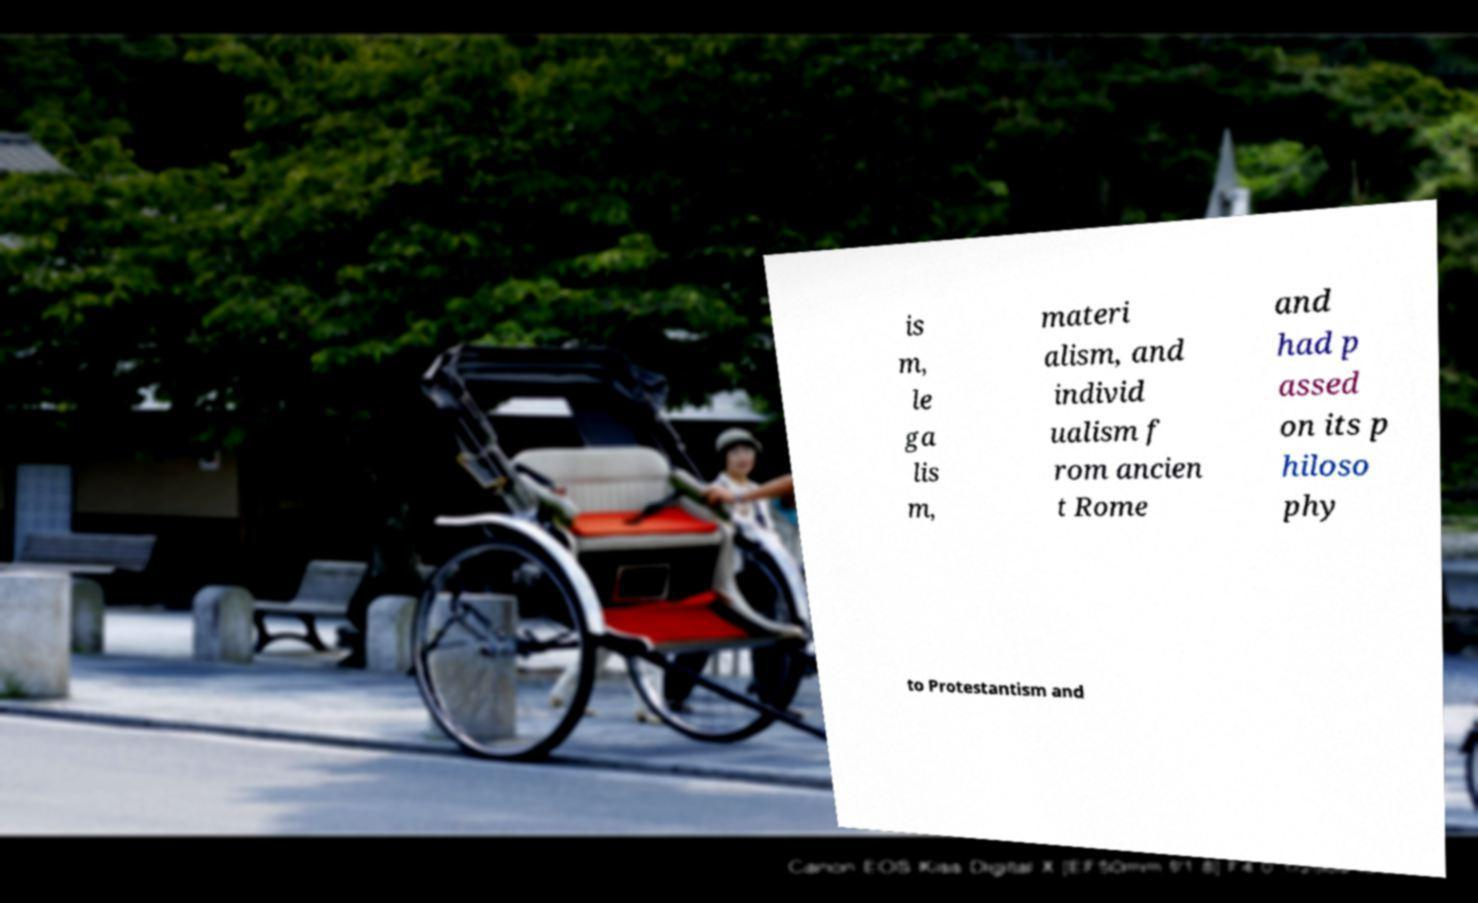Can you read and provide the text displayed in the image?This photo seems to have some interesting text. Can you extract and type it out for me? is m, le ga lis m, materi alism, and individ ualism f rom ancien t Rome and had p assed on its p hiloso phy to Protestantism and 